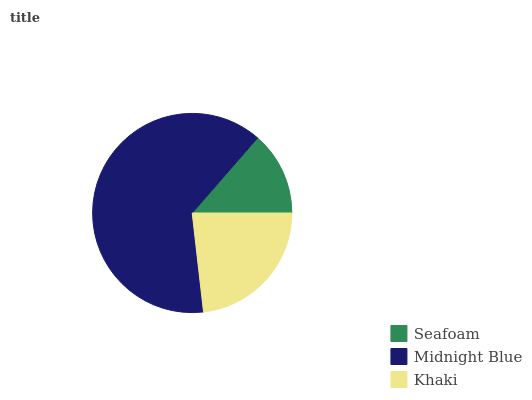Is Seafoam the minimum?
Answer yes or no. Yes. Is Midnight Blue the maximum?
Answer yes or no. Yes. Is Khaki the minimum?
Answer yes or no. No. Is Khaki the maximum?
Answer yes or no. No. Is Midnight Blue greater than Khaki?
Answer yes or no. Yes. Is Khaki less than Midnight Blue?
Answer yes or no. Yes. Is Khaki greater than Midnight Blue?
Answer yes or no. No. Is Midnight Blue less than Khaki?
Answer yes or no. No. Is Khaki the high median?
Answer yes or no. Yes. Is Khaki the low median?
Answer yes or no. Yes. Is Seafoam the high median?
Answer yes or no. No. Is Seafoam the low median?
Answer yes or no. No. 